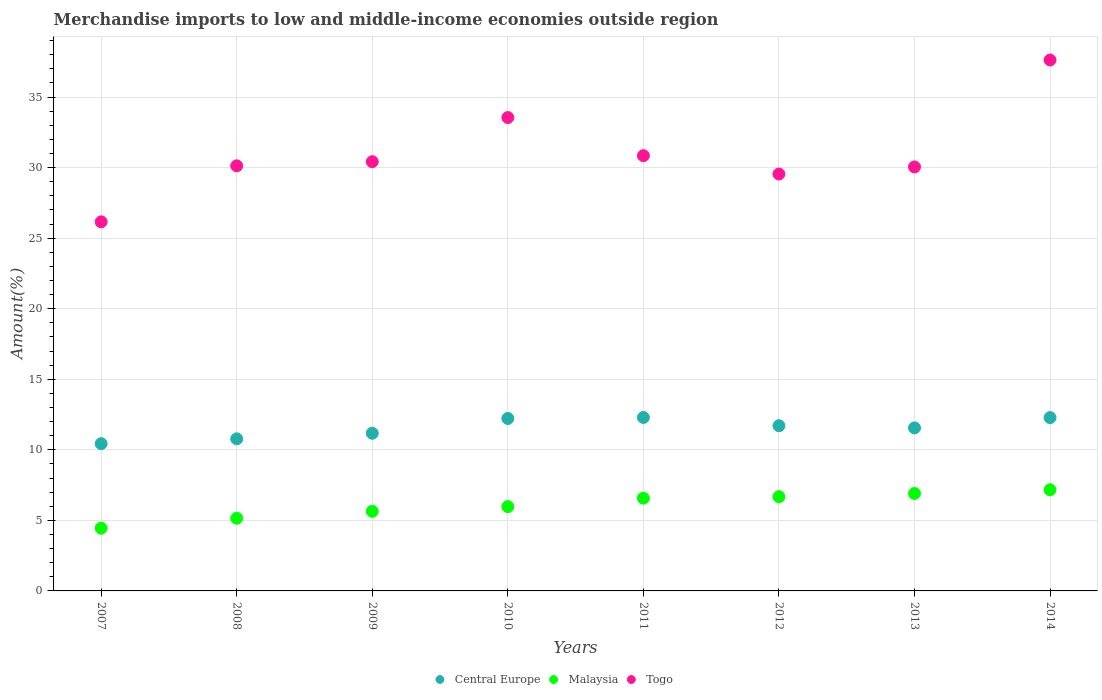What is the percentage of amount earned from merchandise imports in Central Europe in 2007?
Make the answer very short. 10.44. Across all years, what is the maximum percentage of amount earned from merchandise imports in Malaysia?
Your response must be concise. 7.17. Across all years, what is the minimum percentage of amount earned from merchandise imports in Central Europe?
Ensure brevity in your answer.  10.44. In which year was the percentage of amount earned from merchandise imports in Togo maximum?
Offer a very short reply. 2014. What is the total percentage of amount earned from merchandise imports in Togo in the graph?
Your answer should be very brief. 248.32. What is the difference between the percentage of amount earned from merchandise imports in Malaysia in 2008 and that in 2013?
Provide a short and direct response. -1.75. What is the difference between the percentage of amount earned from merchandise imports in Malaysia in 2014 and the percentage of amount earned from merchandise imports in Togo in 2010?
Make the answer very short. -26.38. What is the average percentage of amount earned from merchandise imports in Central Europe per year?
Make the answer very short. 11.56. In the year 2009, what is the difference between the percentage of amount earned from merchandise imports in Central Europe and percentage of amount earned from merchandise imports in Togo?
Offer a very short reply. -19.25. What is the ratio of the percentage of amount earned from merchandise imports in Central Europe in 2009 to that in 2012?
Offer a very short reply. 0.95. What is the difference between the highest and the second highest percentage of amount earned from merchandise imports in Togo?
Provide a short and direct response. 4.08. What is the difference between the highest and the lowest percentage of amount earned from merchandise imports in Togo?
Your answer should be very brief. 11.47. Is the sum of the percentage of amount earned from merchandise imports in Central Europe in 2007 and 2014 greater than the maximum percentage of amount earned from merchandise imports in Malaysia across all years?
Offer a terse response. Yes. Is it the case that in every year, the sum of the percentage of amount earned from merchandise imports in Malaysia and percentage of amount earned from merchandise imports in Togo  is greater than the percentage of amount earned from merchandise imports in Central Europe?
Offer a very short reply. Yes. Is the percentage of amount earned from merchandise imports in Central Europe strictly greater than the percentage of amount earned from merchandise imports in Malaysia over the years?
Provide a succinct answer. Yes. Is the percentage of amount earned from merchandise imports in Malaysia strictly less than the percentage of amount earned from merchandise imports in Central Europe over the years?
Make the answer very short. Yes. How many years are there in the graph?
Your answer should be very brief. 8. What is the difference between two consecutive major ticks on the Y-axis?
Keep it short and to the point. 5. Does the graph contain any zero values?
Ensure brevity in your answer.  No. How many legend labels are there?
Give a very brief answer. 3. What is the title of the graph?
Give a very brief answer. Merchandise imports to low and middle-income economies outside region. What is the label or title of the X-axis?
Offer a very short reply. Years. What is the label or title of the Y-axis?
Give a very brief answer. Amount(%). What is the Amount(%) in Central Europe in 2007?
Your response must be concise. 10.44. What is the Amount(%) in Malaysia in 2007?
Keep it short and to the point. 4.45. What is the Amount(%) in Togo in 2007?
Offer a terse response. 26.16. What is the Amount(%) in Central Europe in 2008?
Ensure brevity in your answer.  10.78. What is the Amount(%) of Malaysia in 2008?
Your answer should be compact. 5.15. What is the Amount(%) of Togo in 2008?
Keep it short and to the point. 30.13. What is the Amount(%) of Central Europe in 2009?
Make the answer very short. 11.17. What is the Amount(%) in Malaysia in 2009?
Your answer should be very brief. 5.64. What is the Amount(%) in Togo in 2009?
Your answer should be very brief. 30.42. What is the Amount(%) in Central Europe in 2010?
Offer a terse response. 12.22. What is the Amount(%) of Malaysia in 2010?
Your answer should be very brief. 5.97. What is the Amount(%) of Togo in 2010?
Provide a succinct answer. 33.55. What is the Amount(%) in Central Europe in 2011?
Keep it short and to the point. 12.29. What is the Amount(%) of Malaysia in 2011?
Offer a terse response. 6.57. What is the Amount(%) of Togo in 2011?
Provide a succinct answer. 30.85. What is the Amount(%) of Central Europe in 2012?
Your answer should be compact. 11.71. What is the Amount(%) in Malaysia in 2012?
Give a very brief answer. 6.68. What is the Amount(%) of Togo in 2012?
Provide a succinct answer. 29.55. What is the Amount(%) of Central Europe in 2013?
Keep it short and to the point. 11.55. What is the Amount(%) in Malaysia in 2013?
Ensure brevity in your answer.  6.91. What is the Amount(%) in Togo in 2013?
Keep it short and to the point. 30.05. What is the Amount(%) of Central Europe in 2014?
Your response must be concise. 12.28. What is the Amount(%) of Malaysia in 2014?
Your answer should be very brief. 7.17. What is the Amount(%) in Togo in 2014?
Your answer should be compact. 37.63. Across all years, what is the maximum Amount(%) of Central Europe?
Offer a terse response. 12.29. Across all years, what is the maximum Amount(%) in Malaysia?
Offer a very short reply. 7.17. Across all years, what is the maximum Amount(%) in Togo?
Give a very brief answer. 37.63. Across all years, what is the minimum Amount(%) in Central Europe?
Make the answer very short. 10.44. Across all years, what is the minimum Amount(%) of Malaysia?
Give a very brief answer. 4.45. Across all years, what is the minimum Amount(%) in Togo?
Your answer should be compact. 26.16. What is the total Amount(%) in Central Europe in the graph?
Make the answer very short. 92.45. What is the total Amount(%) of Malaysia in the graph?
Your response must be concise. 48.54. What is the total Amount(%) in Togo in the graph?
Offer a terse response. 248.32. What is the difference between the Amount(%) of Central Europe in 2007 and that in 2008?
Offer a very short reply. -0.34. What is the difference between the Amount(%) in Malaysia in 2007 and that in 2008?
Keep it short and to the point. -0.71. What is the difference between the Amount(%) of Togo in 2007 and that in 2008?
Make the answer very short. -3.97. What is the difference between the Amount(%) of Central Europe in 2007 and that in 2009?
Give a very brief answer. -0.74. What is the difference between the Amount(%) of Malaysia in 2007 and that in 2009?
Provide a succinct answer. -1.2. What is the difference between the Amount(%) in Togo in 2007 and that in 2009?
Make the answer very short. -4.26. What is the difference between the Amount(%) in Central Europe in 2007 and that in 2010?
Provide a short and direct response. -1.79. What is the difference between the Amount(%) in Malaysia in 2007 and that in 2010?
Provide a succinct answer. -1.53. What is the difference between the Amount(%) in Togo in 2007 and that in 2010?
Give a very brief answer. -7.39. What is the difference between the Amount(%) in Central Europe in 2007 and that in 2011?
Ensure brevity in your answer.  -1.86. What is the difference between the Amount(%) in Malaysia in 2007 and that in 2011?
Your response must be concise. -2.13. What is the difference between the Amount(%) of Togo in 2007 and that in 2011?
Your answer should be compact. -4.69. What is the difference between the Amount(%) of Central Europe in 2007 and that in 2012?
Keep it short and to the point. -1.27. What is the difference between the Amount(%) in Malaysia in 2007 and that in 2012?
Your answer should be very brief. -2.23. What is the difference between the Amount(%) in Togo in 2007 and that in 2012?
Provide a short and direct response. -3.39. What is the difference between the Amount(%) of Central Europe in 2007 and that in 2013?
Make the answer very short. -1.12. What is the difference between the Amount(%) of Malaysia in 2007 and that in 2013?
Offer a terse response. -2.46. What is the difference between the Amount(%) of Togo in 2007 and that in 2013?
Offer a terse response. -3.89. What is the difference between the Amount(%) in Central Europe in 2007 and that in 2014?
Your answer should be very brief. -1.85. What is the difference between the Amount(%) in Malaysia in 2007 and that in 2014?
Provide a short and direct response. -2.72. What is the difference between the Amount(%) of Togo in 2007 and that in 2014?
Offer a very short reply. -11.47. What is the difference between the Amount(%) in Central Europe in 2008 and that in 2009?
Provide a short and direct response. -0.4. What is the difference between the Amount(%) in Malaysia in 2008 and that in 2009?
Ensure brevity in your answer.  -0.49. What is the difference between the Amount(%) of Togo in 2008 and that in 2009?
Keep it short and to the point. -0.3. What is the difference between the Amount(%) of Central Europe in 2008 and that in 2010?
Your answer should be compact. -1.44. What is the difference between the Amount(%) of Malaysia in 2008 and that in 2010?
Make the answer very short. -0.82. What is the difference between the Amount(%) of Togo in 2008 and that in 2010?
Your response must be concise. -3.42. What is the difference between the Amount(%) in Central Europe in 2008 and that in 2011?
Keep it short and to the point. -1.51. What is the difference between the Amount(%) of Malaysia in 2008 and that in 2011?
Ensure brevity in your answer.  -1.42. What is the difference between the Amount(%) in Togo in 2008 and that in 2011?
Provide a succinct answer. -0.72. What is the difference between the Amount(%) of Central Europe in 2008 and that in 2012?
Make the answer very short. -0.93. What is the difference between the Amount(%) in Malaysia in 2008 and that in 2012?
Make the answer very short. -1.53. What is the difference between the Amount(%) of Togo in 2008 and that in 2012?
Your answer should be very brief. 0.58. What is the difference between the Amount(%) in Central Europe in 2008 and that in 2013?
Give a very brief answer. -0.78. What is the difference between the Amount(%) of Malaysia in 2008 and that in 2013?
Give a very brief answer. -1.75. What is the difference between the Amount(%) of Togo in 2008 and that in 2013?
Your answer should be very brief. 0.08. What is the difference between the Amount(%) of Central Europe in 2008 and that in 2014?
Ensure brevity in your answer.  -1.5. What is the difference between the Amount(%) in Malaysia in 2008 and that in 2014?
Offer a very short reply. -2.02. What is the difference between the Amount(%) of Togo in 2008 and that in 2014?
Offer a terse response. -7.5. What is the difference between the Amount(%) of Central Europe in 2009 and that in 2010?
Your answer should be compact. -1.05. What is the difference between the Amount(%) of Malaysia in 2009 and that in 2010?
Your answer should be very brief. -0.33. What is the difference between the Amount(%) of Togo in 2009 and that in 2010?
Give a very brief answer. -3.13. What is the difference between the Amount(%) in Central Europe in 2009 and that in 2011?
Keep it short and to the point. -1.12. What is the difference between the Amount(%) in Malaysia in 2009 and that in 2011?
Your response must be concise. -0.93. What is the difference between the Amount(%) of Togo in 2009 and that in 2011?
Ensure brevity in your answer.  -0.42. What is the difference between the Amount(%) of Central Europe in 2009 and that in 2012?
Ensure brevity in your answer.  -0.53. What is the difference between the Amount(%) in Malaysia in 2009 and that in 2012?
Give a very brief answer. -1.04. What is the difference between the Amount(%) of Togo in 2009 and that in 2012?
Provide a succinct answer. 0.88. What is the difference between the Amount(%) in Central Europe in 2009 and that in 2013?
Make the answer very short. -0.38. What is the difference between the Amount(%) in Malaysia in 2009 and that in 2013?
Ensure brevity in your answer.  -1.26. What is the difference between the Amount(%) of Togo in 2009 and that in 2013?
Offer a very short reply. 0.37. What is the difference between the Amount(%) of Central Europe in 2009 and that in 2014?
Your answer should be compact. -1.11. What is the difference between the Amount(%) in Malaysia in 2009 and that in 2014?
Your answer should be compact. -1.53. What is the difference between the Amount(%) in Togo in 2009 and that in 2014?
Your response must be concise. -7.21. What is the difference between the Amount(%) of Central Europe in 2010 and that in 2011?
Ensure brevity in your answer.  -0.07. What is the difference between the Amount(%) of Malaysia in 2010 and that in 2011?
Make the answer very short. -0.6. What is the difference between the Amount(%) in Togo in 2010 and that in 2011?
Ensure brevity in your answer.  2.7. What is the difference between the Amount(%) in Central Europe in 2010 and that in 2012?
Make the answer very short. 0.51. What is the difference between the Amount(%) in Malaysia in 2010 and that in 2012?
Keep it short and to the point. -0.7. What is the difference between the Amount(%) in Togo in 2010 and that in 2012?
Offer a terse response. 4. What is the difference between the Amount(%) of Central Europe in 2010 and that in 2013?
Offer a very short reply. 0.67. What is the difference between the Amount(%) of Malaysia in 2010 and that in 2013?
Provide a short and direct response. -0.93. What is the difference between the Amount(%) in Togo in 2010 and that in 2013?
Your response must be concise. 3.5. What is the difference between the Amount(%) of Central Europe in 2010 and that in 2014?
Your response must be concise. -0.06. What is the difference between the Amount(%) of Malaysia in 2010 and that in 2014?
Give a very brief answer. -1.19. What is the difference between the Amount(%) in Togo in 2010 and that in 2014?
Provide a succinct answer. -4.08. What is the difference between the Amount(%) in Central Europe in 2011 and that in 2012?
Ensure brevity in your answer.  0.58. What is the difference between the Amount(%) in Malaysia in 2011 and that in 2012?
Provide a succinct answer. -0.11. What is the difference between the Amount(%) of Central Europe in 2011 and that in 2013?
Keep it short and to the point. 0.74. What is the difference between the Amount(%) in Malaysia in 2011 and that in 2013?
Give a very brief answer. -0.33. What is the difference between the Amount(%) of Togo in 2011 and that in 2013?
Provide a succinct answer. 0.8. What is the difference between the Amount(%) in Central Europe in 2011 and that in 2014?
Provide a succinct answer. 0.01. What is the difference between the Amount(%) of Malaysia in 2011 and that in 2014?
Your answer should be very brief. -0.6. What is the difference between the Amount(%) of Togo in 2011 and that in 2014?
Provide a short and direct response. -6.78. What is the difference between the Amount(%) of Central Europe in 2012 and that in 2013?
Offer a very short reply. 0.15. What is the difference between the Amount(%) in Malaysia in 2012 and that in 2013?
Your answer should be compact. -0.23. What is the difference between the Amount(%) of Togo in 2012 and that in 2013?
Offer a very short reply. -0.5. What is the difference between the Amount(%) in Central Europe in 2012 and that in 2014?
Keep it short and to the point. -0.57. What is the difference between the Amount(%) in Malaysia in 2012 and that in 2014?
Make the answer very short. -0.49. What is the difference between the Amount(%) of Togo in 2012 and that in 2014?
Provide a succinct answer. -8.08. What is the difference between the Amount(%) of Central Europe in 2013 and that in 2014?
Offer a terse response. -0.73. What is the difference between the Amount(%) of Malaysia in 2013 and that in 2014?
Make the answer very short. -0.26. What is the difference between the Amount(%) in Togo in 2013 and that in 2014?
Ensure brevity in your answer.  -7.58. What is the difference between the Amount(%) of Central Europe in 2007 and the Amount(%) of Malaysia in 2008?
Keep it short and to the point. 5.28. What is the difference between the Amount(%) of Central Europe in 2007 and the Amount(%) of Togo in 2008?
Provide a succinct answer. -19.69. What is the difference between the Amount(%) in Malaysia in 2007 and the Amount(%) in Togo in 2008?
Give a very brief answer. -25.68. What is the difference between the Amount(%) of Central Europe in 2007 and the Amount(%) of Malaysia in 2009?
Ensure brevity in your answer.  4.79. What is the difference between the Amount(%) in Central Europe in 2007 and the Amount(%) in Togo in 2009?
Offer a terse response. -19.98. What is the difference between the Amount(%) of Malaysia in 2007 and the Amount(%) of Togo in 2009?
Offer a terse response. -25.97. What is the difference between the Amount(%) of Central Europe in 2007 and the Amount(%) of Malaysia in 2010?
Make the answer very short. 4.46. What is the difference between the Amount(%) of Central Europe in 2007 and the Amount(%) of Togo in 2010?
Make the answer very short. -23.11. What is the difference between the Amount(%) of Malaysia in 2007 and the Amount(%) of Togo in 2010?
Your answer should be compact. -29.1. What is the difference between the Amount(%) in Central Europe in 2007 and the Amount(%) in Malaysia in 2011?
Keep it short and to the point. 3.86. What is the difference between the Amount(%) of Central Europe in 2007 and the Amount(%) of Togo in 2011?
Ensure brevity in your answer.  -20.41. What is the difference between the Amount(%) in Malaysia in 2007 and the Amount(%) in Togo in 2011?
Provide a short and direct response. -26.4. What is the difference between the Amount(%) of Central Europe in 2007 and the Amount(%) of Malaysia in 2012?
Keep it short and to the point. 3.76. What is the difference between the Amount(%) of Central Europe in 2007 and the Amount(%) of Togo in 2012?
Provide a succinct answer. -19.11. What is the difference between the Amount(%) in Malaysia in 2007 and the Amount(%) in Togo in 2012?
Your answer should be very brief. -25.1. What is the difference between the Amount(%) of Central Europe in 2007 and the Amount(%) of Malaysia in 2013?
Offer a very short reply. 3.53. What is the difference between the Amount(%) in Central Europe in 2007 and the Amount(%) in Togo in 2013?
Make the answer very short. -19.61. What is the difference between the Amount(%) in Malaysia in 2007 and the Amount(%) in Togo in 2013?
Provide a short and direct response. -25.6. What is the difference between the Amount(%) in Central Europe in 2007 and the Amount(%) in Malaysia in 2014?
Make the answer very short. 3.27. What is the difference between the Amount(%) of Central Europe in 2007 and the Amount(%) of Togo in 2014?
Your answer should be compact. -27.19. What is the difference between the Amount(%) in Malaysia in 2007 and the Amount(%) in Togo in 2014?
Provide a short and direct response. -33.18. What is the difference between the Amount(%) in Central Europe in 2008 and the Amount(%) in Malaysia in 2009?
Ensure brevity in your answer.  5.14. What is the difference between the Amount(%) of Central Europe in 2008 and the Amount(%) of Togo in 2009?
Your answer should be compact. -19.64. What is the difference between the Amount(%) in Malaysia in 2008 and the Amount(%) in Togo in 2009?
Your answer should be compact. -25.27. What is the difference between the Amount(%) of Central Europe in 2008 and the Amount(%) of Malaysia in 2010?
Your response must be concise. 4.8. What is the difference between the Amount(%) in Central Europe in 2008 and the Amount(%) in Togo in 2010?
Your response must be concise. -22.77. What is the difference between the Amount(%) of Malaysia in 2008 and the Amount(%) of Togo in 2010?
Make the answer very short. -28.4. What is the difference between the Amount(%) of Central Europe in 2008 and the Amount(%) of Malaysia in 2011?
Your answer should be compact. 4.21. What is the difference between the Amount(%) of Central Europe in 2008 and the Amount(%) of Togo in 2011?
Provide a short and direct response. -20.07. What is the difference between the Amount(%) of Malaysia in 2008 and the Amount(%) of Togo in 2011?
Offer a very short reply. -25.69. What is the difference between the Amount(%) of Central Europe in 2008 and the Amount(%) of Malaysia in 2012?
Your response must be concise. 4.1. What is the difference between the Amount(%) of Central Europe in 2008 and the Amount(%) of Togo in 2012?
Make the answer very short. -18.77. What is the difference between the Amount(%) of Malaysia in 2008 and the Amount(%) of Togo in 2012?
Keep it short and to the point. -24.39. What is the difference between the Amount(%) of Central Europe in 2008 and the Amount(%) of Malaysia in 2013?
Provide a succinct answer. 3.87. What is the difference between the Amount(%) of Central Europe in 2008 and the Amount(%) of Togo in 2013?
Give a very brief answer. -19.27. What is the difference between the Amount(%) of Malaysia in 2008 and the Amount(%) of Togo in 2013?
Provide a short and direct response. -24.89. What is the difference between the Amount(%) in Central Europe in 2008 and the Amount(%) in Malaysia in 2014?
Offer a very short reply. 3.61. What is the difference between the Amount(%) of Central Europe in 2008 and the Amount(%) of Togo in 2014?
Your answer should be very brief. -26.85. What is the difference between the Amount(%) of Malaysia in 2008 and the Amount(%) of Togo in 2014?
Your answer should be very brief. -32.47. What is the difference between the Amount(%) in Central Europe in 2009 and the Amount(%) in Malaysia in 2010?
Your answer should be compact. 5.2. What is the difference between the Amount(%) of Central Europe in 2009 and the Amount(%) of Togo in 2010?
Make the answer very short. -22.37. What is the difference between the Amount(%) of Malaysia in 2009 and the Amount(%) of Togo in 2010?
Your answer should be compact. -27.91. What is the difference between the Amount(%) of Central Europe in 2009 and the Amount(%) of Malaysia in 2011?
Keep it short and to the point. 4.6. What is the difference between the Amount(%) of Central Europe in 2009 and the Amount(%) of Togo in 2011?
Give a very brief answer. -19.67. What is the difference between the Amount(%) of Malaysia in 2009 and the Amount(%) of Togo in 2011?
Offer a very short reply. -25.2. What is the difference between the Amount(%) in Central Europe in 2009 and the Amount(%) in Malaysia in 2012?
Your response must be concise. 4.5. What is the difference between the Amount(%) in Central Europe in 2009 and the Amount(%) in Togo in 2012?
Provide a short and direct response. -18.37. What is the difference between the Amount(%) of Malaysia in 2009 and the Amount(%) of Togo in 2012?
Make the answer very short. -23.9. What is the difference between the Amount(%) of Central Europe in 2009 and the Amount(%) of Malaysia in 2013?
Make the answer very short. 4.27. What is the difference between the Amount(%) of Central Europe in 2009 and the Amount(%) of Togo in 2013?
Provide a short and direct response. -18.87. What is the difference between the Amount(%) in Malaysia in 2009 and the Amount(%) in Togo in 2013?
Offer a terse response. -24.41. What is the difference between the Amount(%) in Central Europe in 2009 and the Amount(%) in Malaysia in 2014?
Keep it short and to the point. 4.01. What is the difference between the Amount(%) in Central Europe in 2009 and the Amount(%) in Togo in 2014?
Provide a short and direct response. -26.45. What is the difference between the Amount(%) of Malaysia in 2009 and the Amount(%) of Togo in 2014?
Make the answer very short. -31.99. What is the difference between the Amount(%) in Central Europe in 2010 and the Amount(%) in Malaysia in 2011?
Offer a terse response. 5.65. What is the difference between the Amount(%) in Central Europe in 2010 and the Amount(%) in Togo in 2011?
Provide a succinct answer. -18.62. What is the difference between the Amount(%) in Malaysia in 2010 and the Amount(%) in Togo in 2011?
Your answer should be compact. -24.87. What is the difference between the Amount(%) of Central Europe in 2010 and the Amount(%) of Malaysia in 2012?
Offer a terse response. 5.54. What is the difference between the Amount(%) of Central Europe in 2010 and the Amount(%) of Togo in 2012?
Provide a succinct answer. -17.32. What is the difference between the Amount(%) of Malaysia in 2010 and the Amount(%) of Togo in 2012?
Provide a short and direct response. -23.57. What is the difference between the Amount(%) in Central Europe in 2010 and the Amount(%) in Malaysia in 2013?
Offer a terse response. 5.32. What is the difference between the Amount(%) in Central Europe in 2010 and the Amount(%) in Togo in 2013?
Give a very brief answer. -17.83. What is the difference between the Amount(%) in Malaysia in 2010 and the Amount(%) in Togo in 2013?
Provide a succinct answer. -24.07. What is the difference between the Amount(%) in Central Europe in 2010 and the Amount(%) in Malaysia in 2014?
Offer a terse response. 5.05. What is the difference between the Amount(%) in Central Europe in 2010 and the Amount(%) in Togo in 2014?
Keep it short and to the point. -25.41. What is the difference between the Amount(%) in Malaysia in 2010 and the Amount(%) in Togo in 2014?
Provide a succinct answer. -31.65. What is the difference between the Amount(%) of Central Europe in 2011 and the Amount(%) of Malaysia in 2012?
Make the answer very short. 5.61. What is the difference between the Amount(%) in Central Europe in 2011 and the Amount(%) in Togo in 2012?
Offer a terse response. -17.25. What is the difference between the Amount(%) in Malaysia in 2011 and the Amount(%) in Togo in 2012?
Give a very brief answer. -22.97. What is the difference between the Amount(%) of Central Europe in 2011 and the Amount(%) of Malaysia in 2013?
Your answer should be very brief. 5.39. What is the difference between the Amount(%) in Central Europe in 2011 and the Amount(%) in Togo in 2013?
Make the answer very short. -17.75. What is the difference between the Amount(%) in Malaysia in 2011 and the Amount(%) in Togo in 2013?
Offer a terse response. -23.47. What is the difference between the Amount(%) in Central Europe in 2011 and the Amount(%) in Malaysia in 2014?
Ensure brevity in your answer.  5.12. What is the difference between the Amount(%) of Central Europe in 2011 and the Amount(%) of Togo in 2014?
Give a very brief answer. -25.34. What is the difference between the Amount(%) in Malaysia in 2011 and the Amount(%) in Togo in 2014?
Provide a succinct answer. -31.05. What is the difference between the Amount(%) in Central Europe in 2012 and the Amount(%) in Malaysia in 2013?
Provide a succinct answer. 4.8. What is the difference between the Amount(%) in Central Europe in 2012 and the Amount(%) in Togo in 2013?
Provide a short and direct response. -18.34. What is the difference between the Amount(%) of Malaysia in 2012 and the Amount(%) of Togo in 2013?
Provide a succinct answer. -23.37. What is the difference between the Amount(%) in Central Europe in 2012 and the Amount(%) in Malaysia in 2014?
Give a very brief answer. 4.54. What is the difference between the Amount(%) of Central Europe in 2012 and the Amount(%) of Togo in 2014?
Give a very brief answer. -25.92. What is the difference between the Amount(%) in Malaysia in 2012 and the Amount(%) in Togo in 2014?
Provide a short and direct response. -30.95. What is the difference between the Amount(%) of Central Europe in 2013 and the Amount(%) of Malaysia in 2014?
Offer a terse response. 4.39. What is the difference between the Amount(%) in Central Europe in 2013 and the Amount(%) in Togo in 2014?
Offer a very short reply. -26.07. What is the difference between the Amount(%) in Malaysia in 2013 and the Amount(%) in Togo in 2014?
Your response must be concise. -30.72. What is the average Amount(%) of Central Europe per year?
Give a very brief answer. 11.56. What is the average Amount(%) of Malaysia per year?
Offer a terse response. 6.07. What is the average Amount(%) in Togo per year?
Provide a succinct answer. 31.04. In the year 2007, what is the difference between the Amount(%) of Central Europe and Amount(%) of Malaysia?
Your answer should be very brief. 5.99. In the year 2007, what is the difference between the Amount(%) of Central Europe and Amount(%) of Togo?
Your answer should be very brief. -15.72. In the year 2007, what is the difference between the Amount(%) in Malaysia and Amount(%) in Togo?
Offer a terse response. -21.71. In the year 2008, what is the difference between the Amount(%) of Central Europe and Amount(%) of Malaysia?
Make the answer very short. 5.63. In the year 2008, what is the difference between the Amount(%) in Central Europe and Amount(%) in Togo?
Provide a short and direct response. -19.35. In the year 2008, what is the difference between the Amount(%) in Malaysia and Amount(%) in Togo?
Your response must be concise. -24.97. In the year 2009, what is the difference between the Amount(%) of Central Europe and Amount(%) of Malaysia?
Give a very brief answer. 5.53. In the year 2009, what is the difference between the Amount(%) in Central Europe and Amount(%) in Togo?
Keep it short and to the point. -19.25. In the year 2009, what is the difference between the Amount(%) of Malaysia and Amount(%) of Togo?
Provide a succinct answer. -24.78. In the year 2010, what is the difference between the Amount(%) of Central Europe and Amount(%) of Malaysia?
Provide a short and direct response. 6.25. In the year 2010, what is the difference between the Amount(%) in Central Europe and Amount(%) in Togo?
Keep it short and to the point. -21.33. In the year 2010, what is the difference between the Amount(%) of Malaysia and Amount(%) of Togo?
Make the answer very short. -27.57. In the year 2011, what is the difference between the Amount(%) of Central Europe and Amount(%) of Malaysia?
Your answer should be compact. 5.72. In the year 2011, what is the difference between the Amount(%) in Central Europe and Amount(%) in Togo?
Your response must be concise. -18.55. In the year 2011, what is the difference between the Amount(%) in Malaysia and Amount(%) in Togo?
Provide a succinct answer. -24.27. In the year 2012, what is the difference between the Amount(%) of Central Europe and Amount(%) of Malaysia?
Offer a very short reply. 5.03. In the year 2012, what is the difference between the Amount(%) of Central Europe and Amount(%) of Togo?
Make the answer very short. -17.84. In the year 2012, what is the difference between the Amount(%) of Malaysia and Amount(%) of Togo?
Your response must be concise. -22.87. In the year 2013, what is the difference between the Amount(%) of Central Europe and Amount(%) of Malaysia?
Provide a short and direct response. 4.65. In the year 2013, what is the difference between the Amount(%) of Central Europe and Amount(%) of Togo?
Your answer should be compact. -18.49. In the year 2013, what is the difference between the Amount(%) in Malaysia and Amount(%) in Togo?
Ensure brevity in your answer.  -23.14. In the year 2014, what is the difference between the Amount(%) in Central Europe and Amount(%) in Malaysia?
Provide a succinct answer. 5.11. In the year 2014, what is the difference between the Amount(%) of Central Europe and Amount(%) of Togo?
Keep it short and to the point. -25.35. In the year 2014, what is the difference between the Amount(%) of Malaysia and Amount(%) of Togo?
Provide a succinct answer. -30.46. What is the ratio of the Amount(%) in Central Europe in 2007 to that in 2008?
Your answer should be very brief. 0.97. What is the ratio of the Amount(%) of Malaysia in 2007 to that in 2008?
Provide a short and direct response. 0.86. What is the ratio of the Amount(%) in Togo in 2007 to that in 2008?
Ensure brevity in your answer.  0.87. What is the ratio of the Amount(%) in Central Europe in 2007 to that in 2009?
Give a very brief answer. 0.93. What is the ratio of the Amount(%) in Malaysia in 2007 to that in 2009?
Offer a very short reply. 0.79. What is the ratio of the Amount(%) in Togo in 2007 to that in 2009?
Offer a very short reply. 0.86. What is the ratio of the Amount(%) of Central Europe in 2007 to that in 2010?
Your answer should be very brief. 0.85. What is the ratio of the Amount(%) in Malaysia in 2007 to that in 2010?
Provide a short and direct response. 0.74. What is the ratio of the Amount(%) in Togo in 2007 to that in 2010?
Offer a very short reply. 0.78. What is the ratio of the Amount(%) of Central Europe in 2007 to that in 2011?
Your response must be concise. 0.85. What is the ratio of the Amount(%) of Malaysia in 2007 to that in 2011?
Keep it short and to the point. 0.68. What is the ratio of the Amount(%) in Togo in 2007 to that in 2011?
Your response must be concise. 0.85. What is the ratio of the Amount(%) of Central Europe in 2007 to that in 2012?
Provide a short and direct response. 0.89. What is the ratio of the Amount(%) in Malaysia in 2007 to that in 2012?
Offer a very short reply. 0.67. What is the ratio of the Amount(%) of Togo in 2007 to that in 2012?
Your answer should be compact. 0.89. What is the ratio of the Amount(%) in Central Europe in 2007 to that in 2013?
Your answer should be compact. 0.9. What is the ratio of the Amount(%) in Malaysia in 2007 to that in 2013?
Provide a succinct answer. 0.64. What is the ratio of the Amount(%) of Togo in 2007 to that in 2013?
Give a very brief answer. 0.87. What is the ratio of the Amount(%) of Central Europe in 2007 to that in 2014?
Ensure brevity in your answer.  0.85. What is the ratio of the Amount(%) in Malaysia in 2007 to that in 2014?
Keep it short and to the point. 0.62. What is the ratio of the Amount(%) in Togo in 2007 to that in 2014?
Your response must be concise. 0.7. What is the ratio of the Amount(%) in Central Europe in 2008 to that in 2009?
Keep it short and to the point. 0.96. What is the ratio of the Amount(%) of Malaysia in 2008 to that in 2009?
Give a very brief answer. 0.91. What is the ratio of the Amount(%) of Togo in 2008 to that in 2009?
Keep it short and to the point. 0.99. What is the ratio of the Amount(%) of Central Europe in 2008 to that in 2010?
Make the answer very short. 0.88. What is the ratio of the Amount(%) in Malaysia in 2008 to that in 2010?
Your response must be concise. 0.86. What is the ratio of the Amount(%) in Togo in 2008 to that in 2010?
Give a very brief answer. 0.9. What is the ratio of the Amount(%) of Central Europe in 2008 to that in 2011?
Keep it short and to the point. 0.88. What is the ratio of the Amount(%) of Malaysia in 2008 to that in 2011?
Offer a terse response. 0.78. What is the ratio of the Amount(%) of Togo in 2008 to that in 2011?
Provide a short and direct response. 0.98. What is the ratio of the Amount(%) in Central Europe in 2008 to that in 2012?
Offer a terse response. 0.92. What is the ratio of the Amount(%) of Malaysia in 2008 to that in 2012?
Ensure brevity in your answer.  0.77. What is the ratio of the Amount(%) of Togo in 2008 to that in 2012?
Keep it short and to the point. 1.02. What is the ratio of the Amount(%) in Central Europe in 2008 to that in 2013?
Keep it short and to the point. 0.93. What is the ratio of the Amount(%) of Malaysia in 2008 to that in 2013?
Provide a short and direct response. 0.75. What is the ratio of the Amount(%) in Central Europe in 2008 to that in 2014?
Your answer should be very brief. 0.88. What is the ratio of the Amount(%) of Malaysia in 2008 to that in 2014?
Your answer should be very brief. 0.72. What is the ratio of the Amount(%) of Togo in 2008 to that in 2014?
Offer a terse response. 0.8. What is the ratio of the Amount(%) in Central Europe in 2009 to that in 2010?
Ensure brevity in your answer.  0.91. What is the ratio of the Amount(%) in Malaysia in 2009 to that in 2010?
Ensure brevity in your answer.  0.94. What is the ratio of the Amount(%) of Togo in 2009 to that in 2010?
Your answer should be very brief. 0.91. What is the ratio of the Amount(%) in Central Europe in 2009 to that in 2011?
Offer a very short reply. 0.91. What is the ratio of the Amount(%) in Malaysia in 2009 to that in 2011?
Provide a succinct answer. 0.86. What is the ratio of the Amount(%) of Togo in 2009 to that in 2011?
Ensure brevity in your answer.  0.99. What is the ratio of the Amount(%) in Central Europe in 2009 to that in 2012?
Offer a terse response. 0.95. What is the ratio of the Amount(%) in Malaysia in 2009 to that in 2012?
Offer a very short reply. 0.84. What is the ratio of the Amount(%) in Togo in 2009 to that in 2012?
Provide a succinct answer. 1.03. What is the ratio of the Amount(%) of Central Europe in 2009 to that in 2013?
Provide a short and direct response. 0.97. What is the ratio of the Amount(%) in Malaysia in 2009 to that in 2013?
Give a very brief answer. 0.82. What is the ratio of the Amount(%) in Togo in 2009 to that in 2013?
Offer a terse response. 1.01. What is the ratio of the Amount(%) in Central Europe in 2009 to that in 2014?
Your answer should be compact. 0.91. What is the ratio of the Amount(%) of Malaysia in 2009 to that in 2014?
Your response must be concise. 0.79. What is the ratio of the Amount(%) in Togo in 2009 to that in 2014?
Your response must be concise. 0.81. What is the ratio of the Amount(%) of Central Europe in 2010 to that in 2011?
Offer a very short reply. 0.99. What is the ratio of the Amount(%) of Malaysia in 2010 to that in 2011?
Make the answer very short. 0.91. What is the ratio of the Amount(%) of Togo in 2010 to that in 2011?
Your response must be concise. 1.09. What is the ratio of the Amount(%) in Central Europe in 2010 to that in 2012?
Offer a terse response. 1.04. What is the ratio of the Amount(%) of Malaysia in 2010 to that in 2012?
Your answer should be compact. 0.89. What is the ratio of the Amount(%) in Togo in 2010 to that in 2012?
Offer a terse response. 1.14. What is the ratio of the Amount(%) of Central Europe in 2010 to that in 2013?
Make the answer very short. 1.06. What is the ratio of the Amount(%) of Malaysia in 2010 to that in 2013?
Make the answer very short. 0.87. What is the ratio of the Amount(%) in Togo in 2010 to that in 2013?
Your answer should be compact. 1.12. What is the ratio of the Amount(%) in Malaysia in 2010 to that in 2014?
Offer a terse response. 0.83. What is the ratio of the Amount(%) in Togo in 2010 to that in 2014?
Ensure brevity in your answer.  0.89. What is the ratio of the Amount(%) in Central Europe in 2011 to that in 2012?
Provide a succinct answer. 1.05. What is the ratio of the Amount(%) of Malaysia in 2011 to that in 2012?
Provide a succinct answer. 0.98. What is the ratio of the Amount(%) in Togo in 2011 to that in 2012?
Ensure brevity in your answer.  1.04. What is the ratio of the Amount(%) in Central Europe in 2011 to that in 2013?
Keep it short and to the point. 1.06. What is the ratio of the Amount(%) in Malaysia in 2011 to that in 2013?
Provide a succinct answer. 0.95. What is the ratio of the Amount(%) in Togo in 2011 to that in 2013?
Provide a short and direct response. 1.03. What is the ratio of the Amount(%) in Malaysia in 2011 to that in 2014?
Offer a terse response. 0.92. What is the ratio of the Amount(%) of Togo in 2011 to that in 2014?
Give a very brief answer. 0.82. What is the ratio of the Amount(%) of Central Europe in 2012 to that in 2013?
Your response must be concise. 1.01. What is the ratio of the Amount(%) in Malaysia in 2012 to that in 2013?
Offer a very short reply. 0.97. What is the ratio of the Amount(%) of Togo in 2012 to that in 2013?
Offer a terse response. 0.98. What is the ratio of the Amount(%) in Central Europe in 2012 to that in 2014?
Your response must be concise. 0.95. What is the ratio of the Amount(%) in Malaysia in 2012 to that in 2014?
Offer a terse response. 0.93. What is the ratio of the Amount(%) of Togo in 2012 to that in 2014?
Offer a very short reply. 0.79. What is the ratio of the Amount(%) in Central Europe in 2013 to that in 2014?
Provide a short and direct response. 0.94. What is the ratio of the Amount(%) of Malaysia in 2013 to that in 2014?
Provide a short and direct response. 0.96. What is the ratio of the Amount(%) of Togo in 2013 to that in 2014?
Your answer should be compact. 0.8. What is the difference between the highest and the second highest Amount(%) in Central Europe?
Ensure brevity in your answer.  0.01. What is the difference between the highest and the second highest Amount(%) of Malaysia?
Your answer should be very brief. 0.26. What is the difference between the highest and the second highest Amount(%) in Togo?
Offer a very short reply. 4.08. What is the difference between the highest and the lowest Amount(%) in Central Europe?
Your response must be concise. 1.86. What is the difference between the highest and the lowest Amount(%) of Malaysia?
Your response must be concise. 2.72. What is the difference between the highest and the lowest Amount(%) in Togo?
Your answer should be very brief. 11.47. 